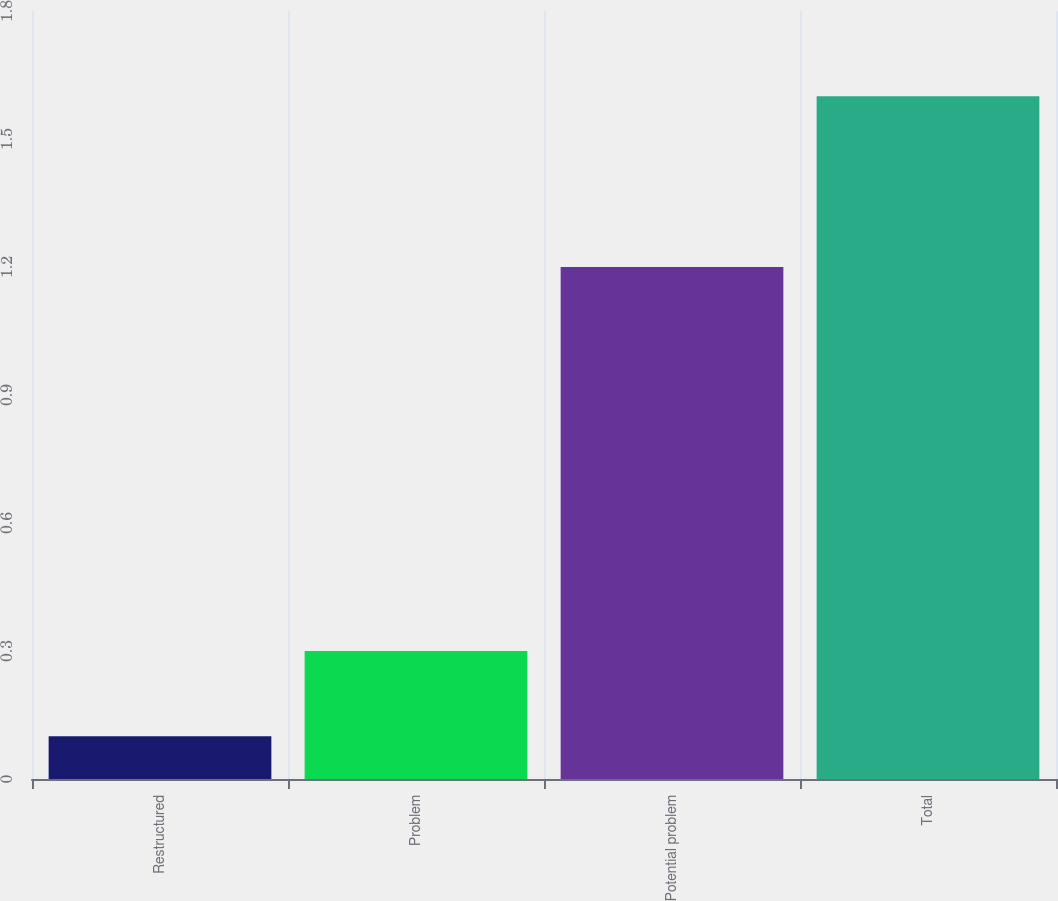Convert chart to OTSL. <chart><loc_0><loc_0><loc_500><loc_500><bar_chart><fcel>Restructured<fcel>Problem<fcel>Potential problem<fcel>Total<nl><fcel>0.1<fcel>0.3<fcel>1.2<fcel>1.6<nl></chart> 